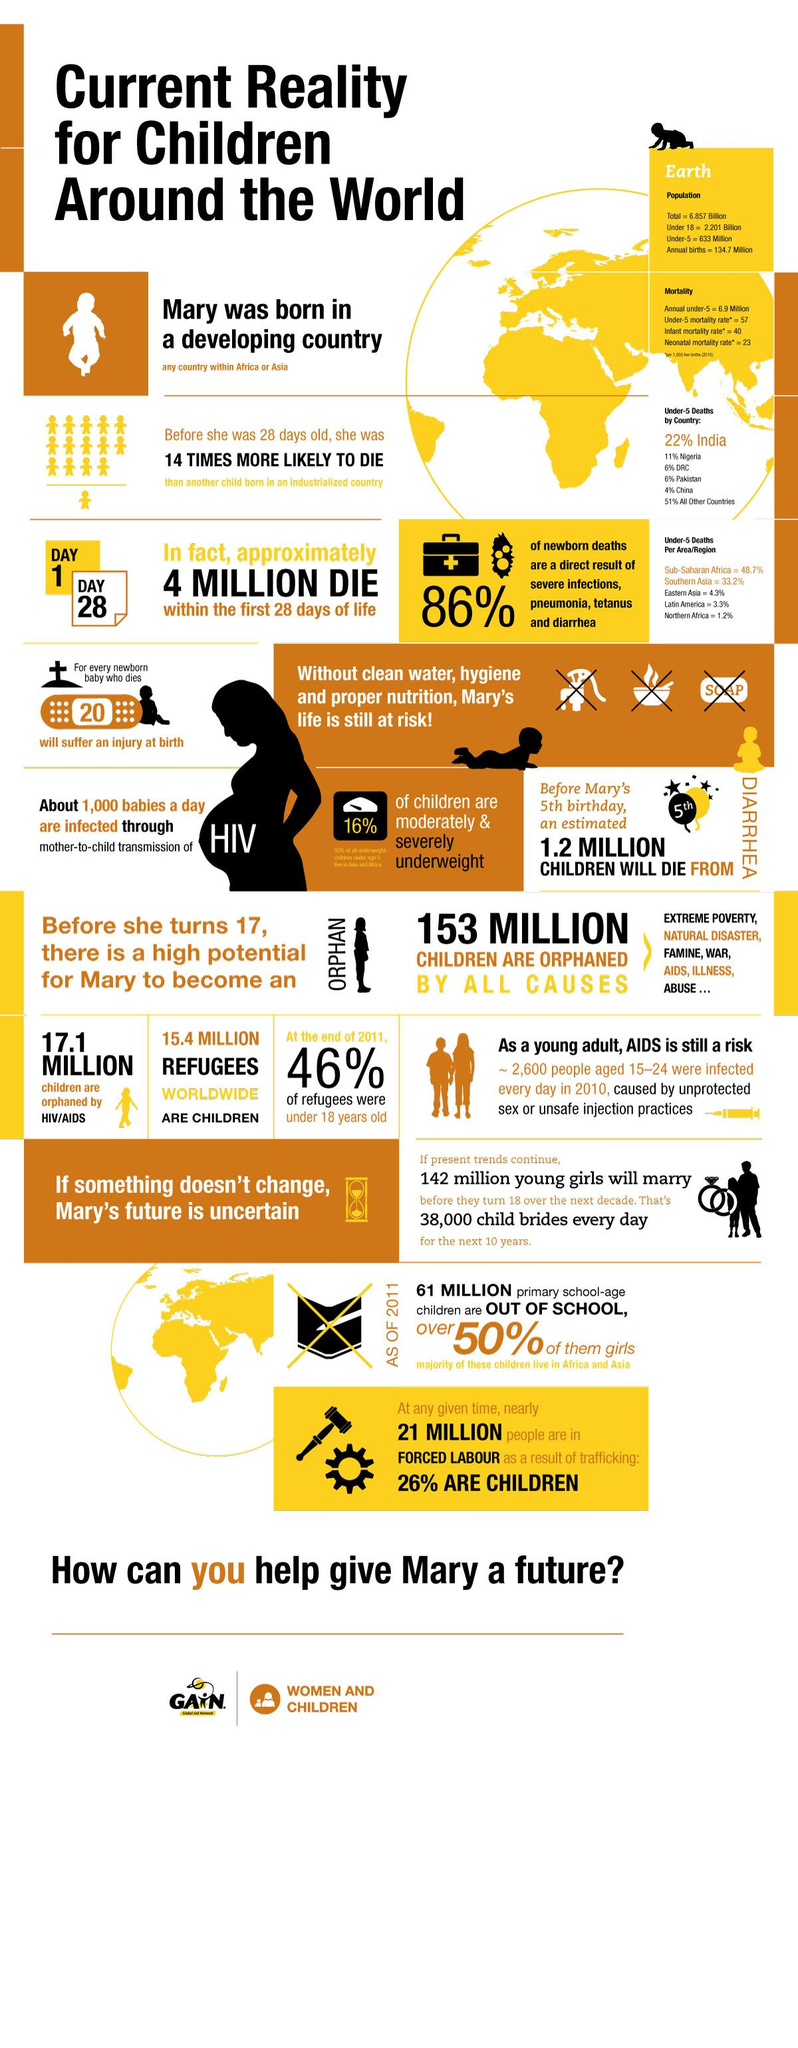List a handful of essential elements in this visual. According to a recent study, it was found that 26% of children are forced into labor as a result of trafficking. As of 2021, an estimated 17.1 million children worldwide have been orphaned by HIV/AIDS. In 2010, the infant mortality rate per 1000 live births was approximately 40. In 2011, 46% of refugees were under the age of 18 at the end of the year. In Pakistan, approximately 6% of deaths among children under the age of 5 occur annually. 